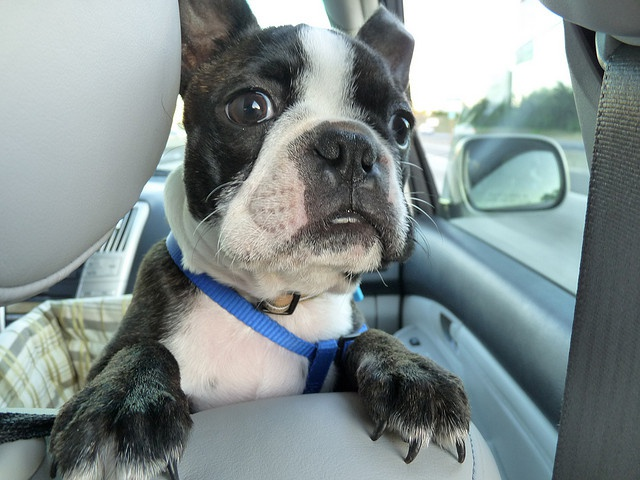Describe the objects in this image and their specific colors. I can see car in gray, darkgray, and white tones and dog in lightgray, black, gray, and darkgray tones in this image. 